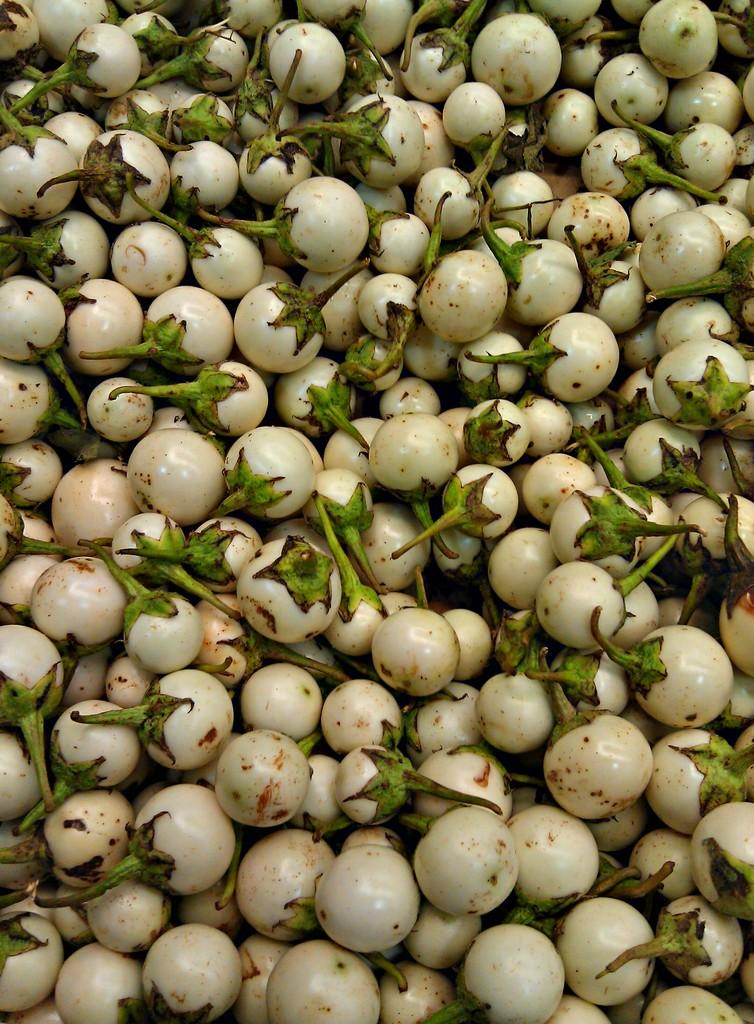What type of food is visible in the image? There are vegetables in the image. What is the color of the vegetables in the image? The vegetables are white in color. What type of stew is being prepared with the vegetables in the image? There is no indication in the image that the vegetables are being used to prepare a stew, as the image only shows the vegetables themselves. 